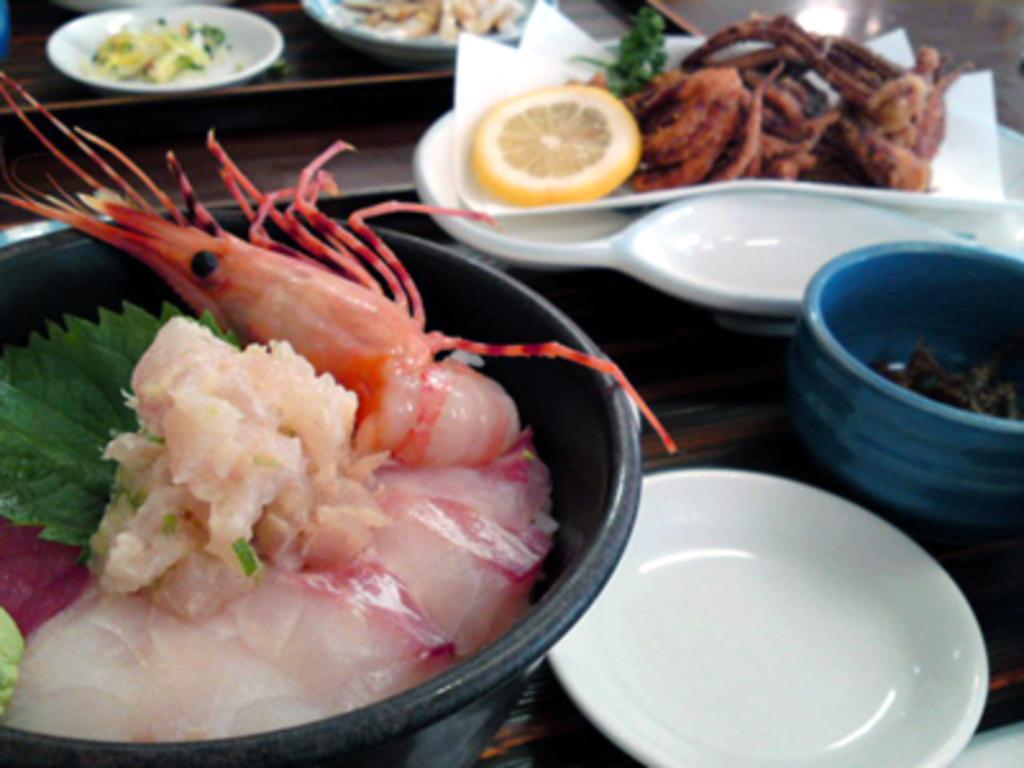Could you give a brief overview of what you see in this image? In this picture we can see a table. On the table we can see plates and a bowl which contains food and we can see the plates which contains food. At the top of the image we can see the floor. 